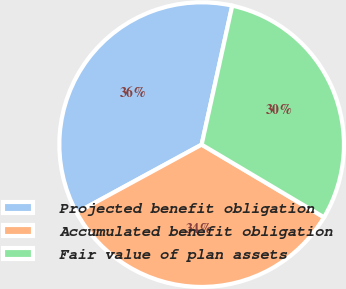Convert chart to OTSL. <chart><loc_0><loc_0><loc_500><loc_500><pie_chart><fcel>Projected benefit obligation<fcel>Accumulated benefit obligation<fcel>Fair value of plan assets<nl><fcel>36.38%<fcel>33.54%<fcel>30.08%<nl></chart> 